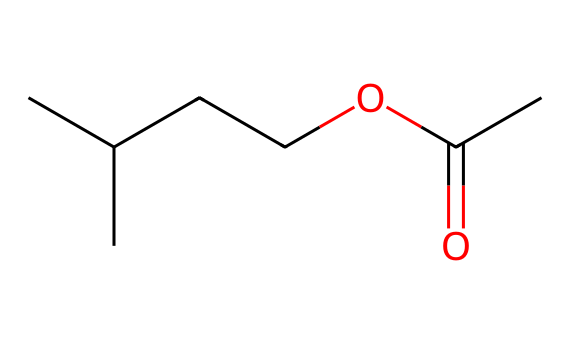how many carbon atoms are in isoamyl acetate? The SMILES representation shows the structure has five carbon atoms in the main chain and two additional carbon atoms from the isopropyl group, making a total of seven.
Answer: seven what functional group is present in isoamyl acetate? In the chemical structure, the carbonyl group (C=O) bonded to an oxygen atom (O) indicates the presence of an ester functional group.
Answer: ester how many hydrogen atoms are in isoamyl acetate? By counting the hydrogen atoms represented in the structure, there are 14 hydrogen atoms in total linked to the carbon atoms.
Answer: fourteen what is the total number of bonds in isoamyl acetate? Counting all the single and double bonds shown in the SMILES representation, there are nine bonds—eight single bonds and one double bond.
Answer: nine what is the common use of isoamyl acetate? Isoamyl acetate is commonly used in the fragrance industry due to its banana-like scent, which makes it popular in perfumes and flavorings.
Answer: fragrance which part of isoamyl acetate gives it its banana scent? The isopentyl group (CC(C)CC) structure is crucial, as it is associated with the specific aroma, contributing to the banana scent characteristic of isoamyl acetate.
Answer: isopentyl group 